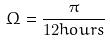<formula> <loc_0><loc_0><loc_500><loc_500>\Omega = \frac { \pi } { 1 2 h o u r s }</formula> 